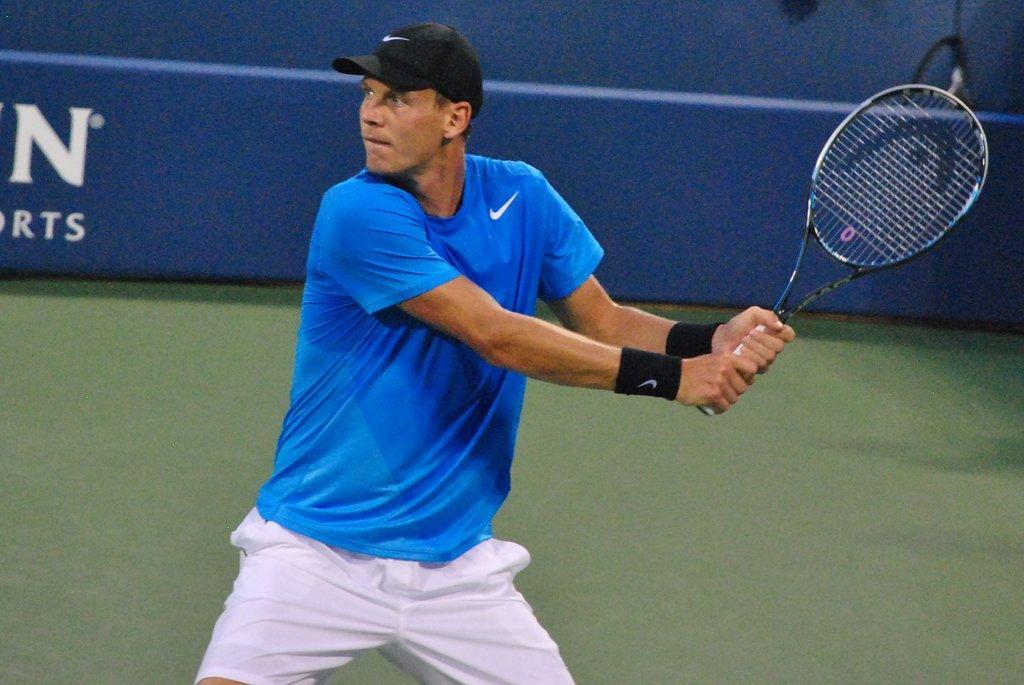Can you describe this image briefly? In this image i can see a man is holding a bat and wearing a cap. 